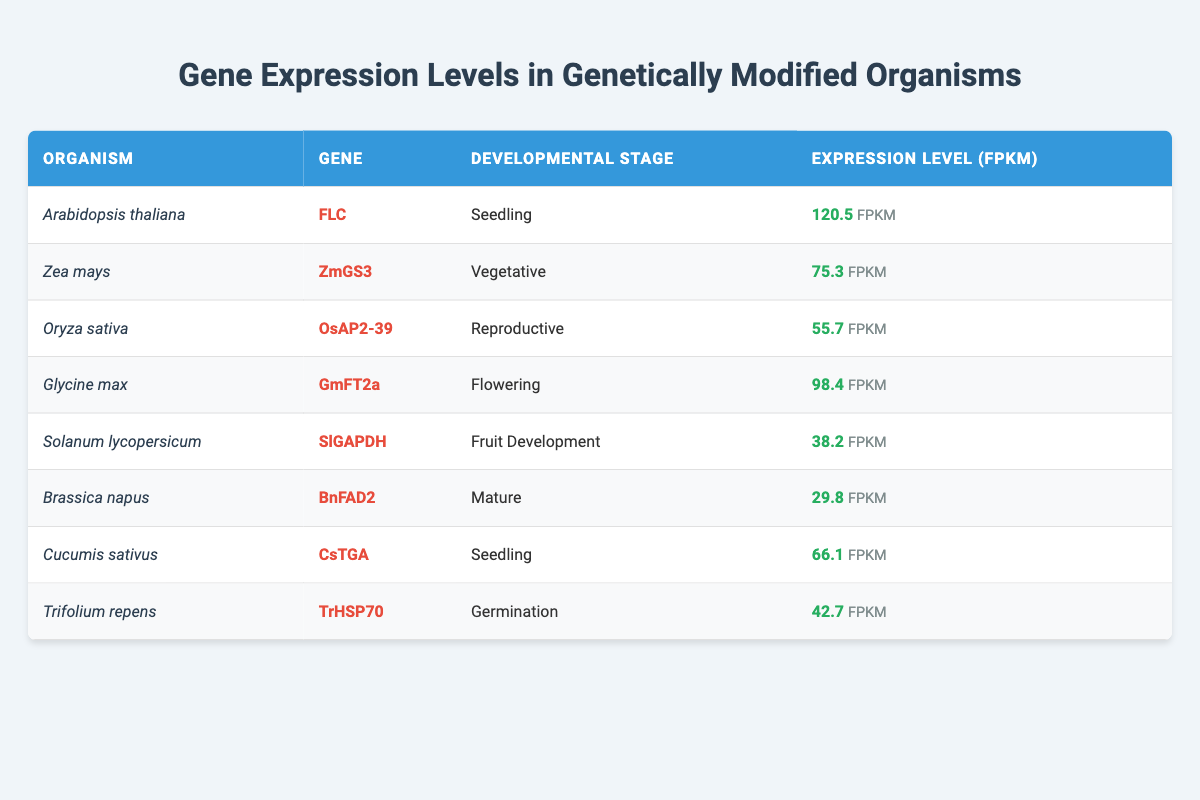What is the expression level of FLC in Arabidopsis thaliana during the seedling stage? The table specifies that the expression level of the gene FLC in Arabidopsis thaliana at the seedling developmental stage is 120.5 FPKM.
Answer: 120.5 FPKM Which gene has the highest expression level among the listed organisms? By comparing the expression levels in the table, Arabidopsis thaliana with FLC has the highest expression level of 120.5 FPKM, while the others are lower.
Answer: FLC What is the expression level of the gene TrHSP70 in Trifolium repens during germination? According to the table, the expression level of TrHSP70 in Trifolium repens at the germination stage is 42.7 FPKM.
Answer: 42.7 FPKM What is the average expression level of the genes in the flowering and reproductive stages? The expression level in the flowering stage (Glycine max, GmFT2a) is 98.4 FPKM and in the reproductive stage (Oryza sativa, OsAP2-39) is 55.7 FPKM. Adding these gives 154.1 FPKM. The average is 154.1/2 = 77.05 FPKM.
Answer: 77.05 FPKM Is the expression level of OsAP2-39 greater than 60 FPKM? The table states that the expression level of OsAP2-39 is 55.7 FPKM, which is less than 60 FPKM.
Answer: No What is the difference in expression level between GmFT2a in Glycine max and OsAP2-39 in Oryza sativa? The expression level of GmFT2a is 98.4 FPKM and OsAP2-39 is 55.7 FPKM. The difference is 98.4 - 55.7 = 42.7 FPKM.
Answer: 42.7 FPKM Which organism has an expression level below 50 FPKM? Upon reviewing the table, Solanum lycopersicum (SlGAPDH) and Brassica napus (BnFAD2) have expression levels of 38.2 FPKM and 29.8 FPKM respectively, both below 50 FPKM.
Answer: Solanum lycopersicum and Brassica napus How many genes are represented for the seedling developmental stage? The table includes two entries for the seedling stage: FLC (Arabidopsis thaliana) and CsTGA (Cucumis sativus). Therefore, there are 2 genes in this developmental stage.
Answer: 2 